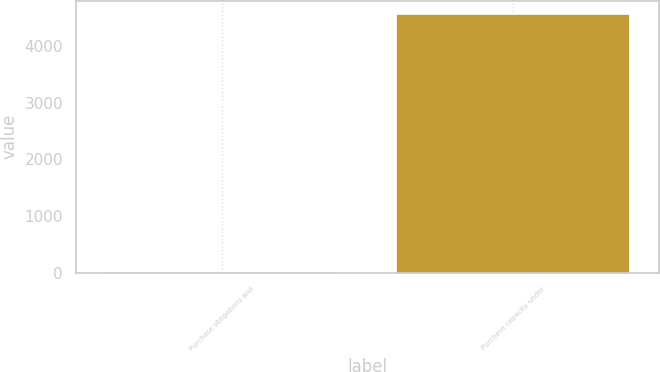Convert chart to OTSL. <chart><loc_0><loc_0><loc_500><loc_500><bar_chart><fcel>Purchase obligations and<fcel>Purchase capacity under<nl><fcel>14.9<fcel>4573<nl></chart> 